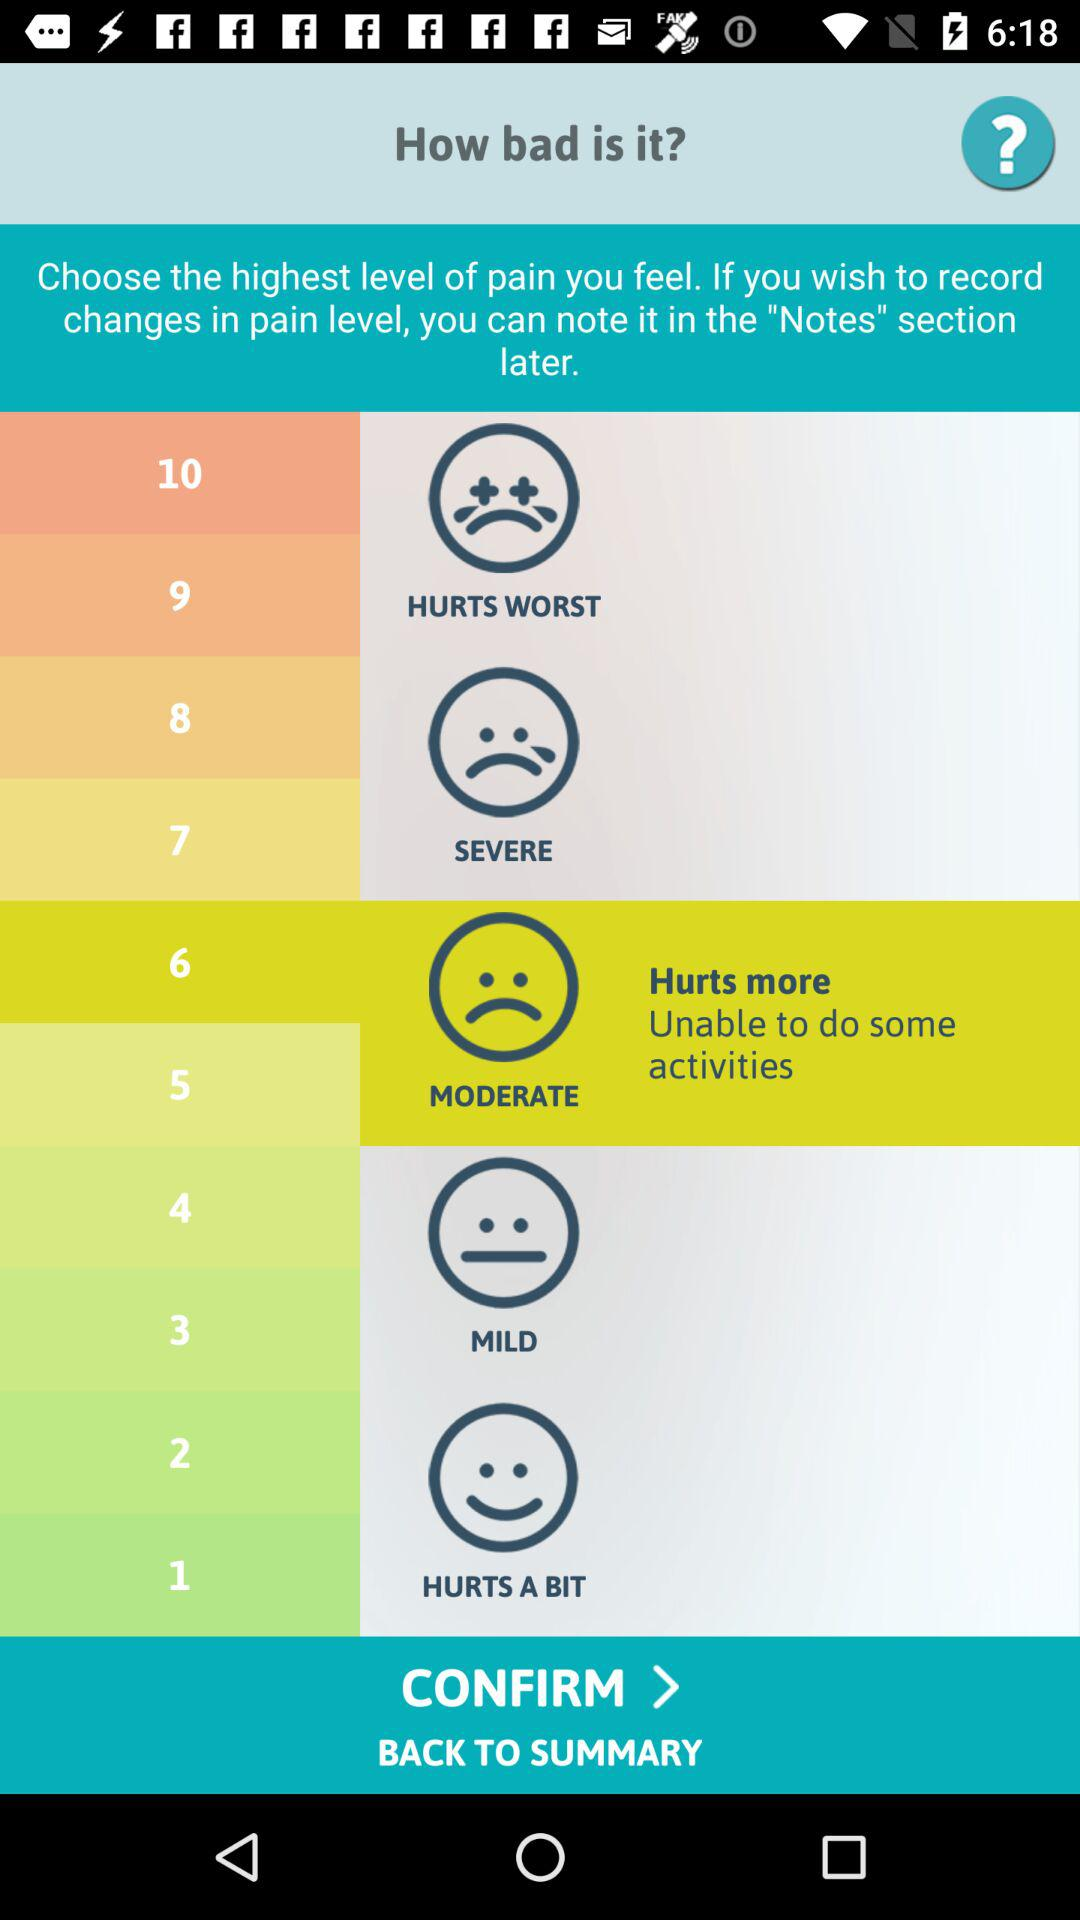What are the level numbers for the "MODERATE" feeling? The level numbers for the "MODERATE" feeling are 5 and 6. 